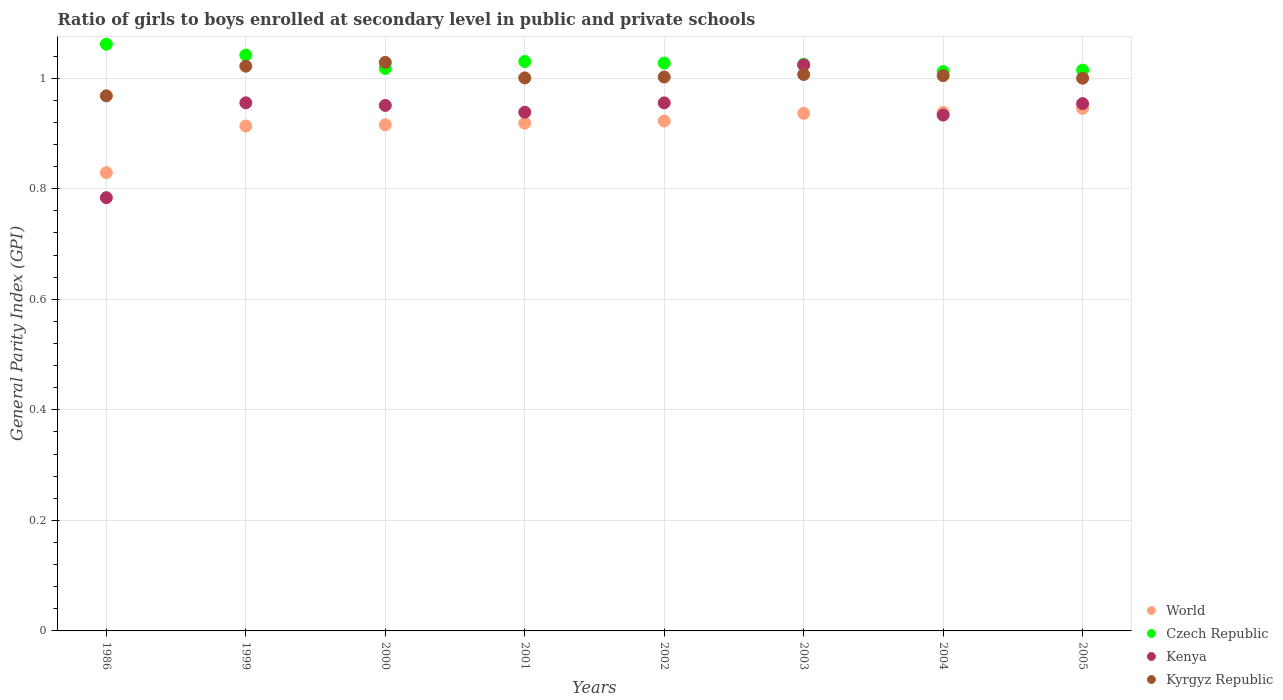Is the number of dotlines equal to the number of legend labels?
Provide a succinct answer. Yes. What is the general parity index in Kyrgyz Republic in 2000?
Offer a terse response. 1.03. Across all years, what is the maximum general parity index in Czech Republic?
Offer a very short reply. 1.06. Across all years, what is the minimum general parity index in World?
Provide a short and direct response. 0.83. In which year was the general parity index in Kenya minimum?
Make the answer very short. 1986. What is the total general parity index in Czech Republic in the graph?
Make the answer very short. 8.23. What is the difference between the general parity index in Czech Republic in 1999 and that in 2005?
Give a very brief answer. 0.03. What is the difference between the general parity index in Kenya in 2003 and the general parity index in Czech Republic in 1999?
Offer a terse response. -0.02. What is the average general parity index in World per year?
Ensure brevity in your answer.  0.92. In the year 2003, what is the difference between the general parity index in Czech Republic and general parity index in Kyrgyz Republic?
Provide a short and direct response. 0.02. What is the ratio of the general parity index in World in 1986 to that in 2001?
Provide a short and direct response. 0.9. Is the difference between the general parity index in Czech Republic in 2000 and 2004 greater than the difference between the general parity index in Kyrgyz Republic in 2000 and 2004?
Make the answer very short. No. What is the difference between the highest and the second highest general parity index in Kenya?
Provide a succinct answer. 0.07. What is the difference between the highest and the lowest general parity index in Kyrgyz Republic?
Give a very brief answer. 0.06. Does the general parity index in Kenya monotonically increase over the years?
Your answer should be compact. No. How many dotlines are there?
Offer a terse response. 4. Are the values on the major ticks of Y-axis written in scientific E-notation?
Make the answer very short. No. Does the graph contain any zero values?
Your response must be concise. No. What is the title of the graph?
Make the answer very short. Ratio of girls to boys enrolled at secondary level in public and private schools. Does "Vanuatu" appear as one of the legend labels in the graph?
Provide a short and direct response. No. What is the label or title of the Y-axis?
Ensure brevity in your answer.  General Parity Index (GPI). What is the General Parity Index (GPI) in World in 1986?
Provide a succinct answer. 0.83. What is the General Parity Index (GPI) of Czech Republic in 1986?
Provide a succinct answer. 1.06. What is the General Parity Index (GPI) in Kenya in 1986?
Keep it short and to the point. 0.78. What is the General Parity Index (GPI) of Kyrgyz Republic in 1986?
Offer a terse response. 0.97. What is the General Parity Index (GPI) of World in 1999?
Provide a succinct answer. 0.91. What is the General Parity Index (GPI) in Czech Republic in 1999?
Give a very brief answer. 1.04. What is the General Parity Index (GPI) of Kenya in 1999?
Make the answer very short. 0.96. What is the General Parity Index (GPI) in Kyrgyz Republic in 1999?
Your response must be concise. 1.02. What is the General Parity Index (GPI) in World in 2000?
Offer a very short reply. 0.92. What is the General Parity Index (GPI) of Czech Republic in 2000?
Offer a very short reply. 1.02. What is the General Parity Index (GPI) of Kenya in 2000?
Give a very brief answer. 0.95. What is the General Parity Index (GPI) in Kyrgyz Republic in 2000?
Give a very brief answer. 1.03. What is the General Parity Index (GPI) in World in 2001?
Keep it short and to the point. 0.92. What is the General Parity Index (GPI) in Czech Republic in 2001?
Offer a very short reply. 1.03. What is the General Parity Index (GPI) in Kenya in 2001?
Offer a terse response. 0.94. What is the General Parity Index (GPI) of Kyrgyz Republic in 2001?
Your answer should be very brief. 1. What is the General Parity Index (GPI) in World in 2002?
Your answer should be compact. 0.92. What is the General Parity Index (GPI) in Czech Republic in 2002?
Your response must be concise. 1.03. What is the General Parity Index (GPI) in Kenya in 2002?
Provide a short and direct response. 0.96. What is the General Parity Index (GPI) in Kyrgyz Republic in 2002?
Your response must be concise. 1. What is the General Parity Index (GPI) of World in 2003?
Ensure brevity in your answer.  0.94. What is the General Parity Index (GPI) in Czech Republic in 2003?
Your answer should be very brief. 1.03. What is the General Parity Index (GPI) of Kenya in 2003?
Provide a short and direct response. 1.02. What is the General Parity Index (GPI) of Kyrgyz Republic in 2003?
Your answer should be very brief. 1.01. What is the General Parity Index (GPI) of World in 2004?
Offer a very short reply. 0.94. What is the General Parity Index (GPI) in Czech Republic in 2004?
Provide a succinct answer. 1.01. What is the General Parity Index (GPI) in Kenya in 2004?
Give a very brief answer. 0.93. What is the General Parity Index (GPI) in Kyrgyz Republic in 2004?
Provide a succinct answer. 1. What is the General Parity Index (GPI) of World in 2005?
Your answer should be very brief. 0.95. What is the General Parity Index (GPI) of Czech Republic in 2005?
Your answer should be compact. 1.01. What is the General Parity Index (GPI) in Kenya in 2005?
Make the answer very short. 0.95. What is the General Parity Index (GPI) of Kyrgyz Republic in 2005?
Your answer should be compact. 1. Across all years, what is the maximum General Parity Index (GPI) of World?
Ensure brevity in your answer.  0.95. Across all years, what is the maximum General Parity Index (GPI) of Czech Republic?
Give a very brief answer. 1.06. Across all years, what is the maximum General Parity Index (GPI) in Kenya?
Offer a terse response. 1.02. Across all years, what is the maximum General Parity Index (GPI) of Kyrgyz Republic?
Offer a very short reply. 1.03. Across all years, what is the minimum General Parity Index (GPI) of World?
Make the answer very short. 0.83. Across all years, what is the minimum General Parity Index (GPI) of Czech Republic?
Provide a short and direct response. 1.01. Across all years, what is the minimum General Parity Index (GPI) of Kenya?
Provide a short and direct response. 0.78. Across all years, what is the minimum General Parity Index (GPI) in Kyrgyz Republic?
Your response must be concise. 0.97. What is the total General Parity Index (GPI) in World in the graph?
Provide a short and direct response. 7.32. What is the total General Parity Index (GPI) of Czech Republic in the graph?
Provide a succinct answer. 8.23. What is the total General Parity Index (GPI) in Kenya in the graph?
Offer a very short reply. 7.5. What is the total General Parity Index (GPI) in Kyrgyz Republic in the graph?
Provide a short and direct response. 8.03. What is the difference between the General Parity Index (GPI) in World in 1986 and that in 1999?
Provide a short and direct response. -0.08. What is the difference between the General Parity Index (GPI) of Czech Republic in 1986 and that in 1999?
Your response must be concise. 0.02. What is the difference between the General Parity Index (GPI) of Kenya in 1986 and that in 1999?
Your answer should be very brief. -0.17. What is the difference between the General Parity Index (GPI) of Kyrgyz Republic in 1986 and that in 1999?
Your answer should be very brief. -0.05. What is the difference between the General Parity Index (GPI) of World in 1986 and that in 2000?
Keep it short and to the point. -0.09. What is the difference between the General Parity Index (GPI) in Czech Republic in 1986 and that in 2000?
Ensure brevity in your answer.  0.04. What is the difference between the General Parity Index (GPI) in Kenya in 1986 and that in 2000?
Your response must be concise. -0.17. What is the difference between the General Parity Index (GPI) of Kyrgyz Republic in 1986 and that in 2000?
Provide a short and direct response. -0.06. What is the difference between the General Parity Index (GPI) of World in 1986 and that in 2001?
Offer a terse response. -0.09. What is the difference between the General Parity Index (GPI) in Czech Republic in 1986 and that in 2001?
Offer a very short reply. 0.03. What is the difference between the General Parity Index (GPI) of Kenya in 1986 and that in 2001?
Your response must be concise. -0.15. What is the difference between the General Parity Index (GPI) in Kyrgyz Republic in 1986 and that in 2001?
Your answer should be very brief. -0.03. What is the difference between the General Parity Index (GPI) in World in 1986 and that in 2002?
Your answer should be compact. -0.09. What is the difference between the General Parity Index (GPI) of Czech Republic in 1986 and that in 2002?
Offer a very short reply. 0.03. What is the difference between the General Parity Index (GPI) of Kenya in 1986 and that in 2002?
Your answer should be compact. -0.17. What is the difference between the General Parity Index (GPI) in Kyrgyz Republic in 1986 and that in 2002?
Keep it short and to the point. -0.03. What is the difference between the General Parity Index (GPI) of World in 1986 and that in 2003?
Offer a very short reply. -0.11. What is the difference between the General Parity Index (GPI) of Czech Republic in 1986 and that in 2003?
Give a very brief answer. 0.04. What is the difference between the General Parity Index (GPI) of Kenya in 1986 and that in 2003?
Keep it short and to the point. -0.24. What is the difference between the General Parity Index (GPI) of Kyrgyz Republic in 1986 and that in 2003?
Provide a short and direct response. -0.04. What is the difference between the General Parity Index (GPI) of World in 1986 and that in 2004?
Offer a very short reply. -0.11. What is the difference between the General Parity Index (GPI) in Czech Republic in 1986 and that in 2004?
Provide a short and direct response. 0.05. What is the difference between the General Parity Index (GPI) of Kenya in 1986 and that in 2004?
Offer a very short reply. -0.15. What is the difference between the General Parity Index (GPI) of Kyrgyz Republic in 1986 and that in 2004?
Make the answer very short. -0.04. What is the difference between the General Parity Index (GPI) in World in 1986 and that in 2005?
Provide a short and direct response. -0.12. What is the difference between the General Parity Index (GPI) of Czech Republic in 1986 and that in 2005?
Provide a short and direct response. 0.05. What is the difference between the General Parity Index (GPI) of Kenya in 1986 and that in 2005?
Offer a very short reply. -0.17. What is the difference between the General Parity Index (GPI) of Kyrgyz Republic in 1986 and that in 2005?
Your answer should be very brief. -0.03. What is the difference between the General Parity Index (GPI) of World in 1999 and that in 2000?
Keep it short and to the point. -0. What is the difference between the General Parity Index (GPI) in Czech Republic in 1999 and that in 2000?
Your response must be concise. 0.02. What is the difference between the General Parity Index (GPI) in Kenya in 1999 and that in 2000?
Provide a succinct answer. 0. What is the difference between the General Parity Index (GPI) in Kyrgyz Republic in 1999 and that in 2000?
Offer a terse response. -0.01. What is the difference between the General Parity Index (GPI) of World in 1999 and that in 2001?
Provide a succinct answer. -0.01. What is the difference between the General Parity Index (GPI) in Czech Republic in 1999 and that in 2001?
Make the answer very short. 0.01. What is the difference between the General Parity Index (GPI) of Kenya in 1999 and that in 2001?
Provide a succinct answer. 0.02. What is the difference between the General Parity Index (GPI) in Kyrgyz Republic in 1999 and that in 2001?
Offer a very short reply. 0.02. What is the difference between the General Parity Index (GPI) in World in 1999 and that in 2002?
Your answer should be very brief. -0.01. What is the difference between the General Parity Index (GPI) in Czech Republic in 1999 and that in 2002?
Your response must be concise. 0.01. What is the difference between the General Parity Index (GPI) in Kyrgyz Republic in 1999 and that in 2002?
Your answer should be compact. 0.02. What is the difference between the General Parity Index (GPI) of World in 1999 and that in 2003?
Your answer should be very brief. -0.02. What is the difference between the General Parity Index (GPI) in Czech Republic in 1999 and that in 2003?
Your answer should be very brief. 0.02. What is the difference between the General Parity Index (GPI) of Kenya in 1999 and that in 2003?
Provide a short and direct response. -0.07. What is the difference between the General Parity Index (GPI) of Kyrgyz Republic in 1999 and that in 2003?
Your answer should be very brief. 0.01. What is the difference between the General Parity Index (GPI) in World in 1999 and that in 2004?
Your answer should be compact. -0.02. What is the difference between the General Parity Index (GPI) in Czech Republic in 1999 and that in 2004?
Your answer should be compact. 0.03. What is the difference between the General Parity Index (GPI) of Kenya in 1999 and that in 2004?
Provide a short and direct response. 0.02. What is the difference between the General Parity Index (GPI) of Kyrgyz Republic in 1999 and that in 2004?
Provide a succinct answer. 0.02. What is the difference between the General Parity Index (GPI) in World in 1999 and that in 2005?
Offer a terse response. -0.03. What is the difference between the General Parity Index (GPI) in Czech Republic in 1999 and that in 2005?
Offer a terse response. 0.03. What is the difference between the General Parity Index (GPI) of Kenya in 1999 and that in 2005?
Offer a terse response. 0. What is the difference between the General Parity Index (GPI) in Kyrgyz Republic in 1999 and that in 2005?
Make the answer very short. 0.02. What is the difference between the General Parity Index (GPI) of World in 2000 and that in 2001?
Your response must be concise. -0. What is the difference between the General Parity Index (GPI) of Czech Republic in 2000 and that in 2001?
Offer a very short reply. -0.01. What is the difference between the General Parity Index (GPI) in Kenya in 2000 and that in 2001?
Your answer should be compact. 0.01. What is the difference between the General Parity Index (GPI) of Kyrgyz Republic in 2000 and that in 2001?
Offer a terse response. 0.03. What is the difference between the General Parity Index (GPI) in World in 2000 and that in 2002?
Ensure brevity in your answer.  -0.01. What is the difference between the General Parity Index (GPI) in Czech Republic in 2000 and that in 2002?
Offer a terse response. -0.01. What is the difference between the General Parity Index (GPI) in Kenya in 2000 and that in 2002?
Your answer should be compact. -0. What is the difference between the General Parity Index (GPI) in Kyrgyz Republic in 2000 and that in 2002?
Offer a very short reply. 0.03. What is the difference between the General Parity Index (GPI) in World in 2000 and that in 2003?
Make the answer very short. -0.02. What is the difference between the General Parity Index (GPI) in Czech Republic in 2000 and that in 2003?
Make the answer very short. -0.01. What is the difference between the General Parity Index (GPI) in Kenya in 2000 and that in 2003?
Give a very brief answer. -0.07. What is the difference between the General Parity Index (GPI) of Kyrgyz Republic in 2000 and that in 2003?
Offer a very short reply. 0.02. What is the difference between the General Parity Index (GPI) of World in 2000 and that in 2004?
Your answer should be very brief. -0.02. What is the difference between the General Parity Index (GPI) of Czech Republic in 2000 and that in 2004?
Provide a succinct answer. 0.01. What is the difference between the General Parity Index (GPI) in Kenya in 2000 and that in 2004?
Keep it short and to the point. 0.02. What is the difference between the General Parity Index (GPI) of Kyrgyz Republic in 2000 and that in 2004?
Ensure brevity in your answer.  0.02. What is the difference between the General Parity Index (GPI) in World in 2000 and that in 2005?
Your answer should be very brief. -0.03. What is the difference between the General Parity Index (GPI) in Czech Republic in 2000 and that in 2005?
Your answer should be compact. 0. What is the difference between the General Parity Index (GPI) in Kenya in 2000 and that in 2005?
Your answer should be compact. -0. What is the difference between the General Parity Index (GPI) in Kyrgyz Republic in 2000 and that in 2005?
Make the answer very short. 0.03. What is the difference between the General Parity Index (GPI) in World in 2001 and that in 2002?
Your answer should be compact. -0. What is the difference between the General Parity Index (GPI) of Czech Republic in 2001 and that in 2002?
Offer a terse response. 0. What is the difference between the General Parity Index (GPI) in Kenya in 2001 and that in 2002?
Make the answer very short. -0.02. What is the difference between the General Parity Index (GPI) of Kyrgyz Republic in 2001 and that in 2002?
Keep it short and to the point. -0. What is the difference between the General Parity Index (GPI) in World in 2001 and that in 2003?
Make the answer very short. -0.02. What is the difference between the General Parity Index (GPI) in Czech Republic in 2001 and that in 2003?
Your answer should be very brief. 0.01. What is the difference between the General Parity Index (GPI) in Kenya in 2001 and that in 2003?
Your answer should be very brief. -0.09. What is the difference between the General Parity Index (GPI) in Kyrgyz Republic in 2001 and that in 2003?
Ensure brevity in your answer.  -0.01. What is the difference between the General Parity Index (GPI) in World in 2001 and that in 2004?
Provide a short and direct response. -0.02. What is the difference between the General Parity Index (GPI) of Czech Republic in 2001 and that in 2004?
Provide a short and direct response. 0.02. What is the difference between the General Parity Index (GPI) in Kenya in 2001 and that in 2004?
Your response must be concise. 0.01. What is the difference between the General Parity Index (GPI) of Kyrgyz Republic in 2001 and that in 2004?
Provide a short and direct response. -0. What is the difference between the General Parity Index (GPI) of World in 2001 and that in 2005?
Provide a short and direct response. -0.03. What is the difference between the General Parity Index (GPI) in Czech Republic in 2001 and that in 2005?
Your answer should be very brief. 0.02. What is the difference between the General Parity Index (GPI) of Kenya in 2001 and that in 2005?
Your answer should be very brief. -0.02. What is the difference between the General Parity Index (GPI) of Kyrgyz Republic in 2001 and that in 2005?
Provide a short and direct response. 0. What is the difference between the General Parity Index (GPI) in World in 2002 and that in 2003?
Ensure brevity in your answer.  -0.01. What is the difference between the General Parity Index (GPI) of Czech Republic in 2002 and that in 2003?
Provide a short and direct response. 0. What is the difference between the General Parity Index (GPI) in Kenya in 2002 and that in 2003?
Your answer should be compact. -0.07. What is the difference between the General Parity Index (GPI) of Kyrgyz Republic in 2002 and that in 2003?
Provide a short and direct response. -0. What is the difference between the General Parity Index (GPI) in World in 2002 and that in 2004?
Your answer should be very brief. -0.02. What is the difference between the General Parity Index (GPI) in Czech Republic in 2002 and that in 2004?
Offer a very short reply. 0.02. What is the difference between the General Parity Index (GPI) of Kenya in 2002 and that in 2004?
Provide a short and direct response. 0.02. What is the difference between the General Parity Index (GPI) in Kyrgyz Republic in 2002 and that in 2004?
Provide a short and direct response. -0. What is the difference between the General Parity Index (GPI) in World in 2002 and that in 2005?
Your answer should be very brief. -0.02. What is the difference between the General Parity Index (GPI) in Czech Republic in 2002 and that in 2005?
Offer a very short reply. 0.01. What is the difference between the General Parity Index (GPI) in Kenya in 2002 and that in 2005?
Make the answer very short. 0. What is the difference between the General Parity Index (GPI) of Kyrgyz Republic in 2002 and that in 2005?
Your response must be concise. 0. What is the difference between the General Parity Index (GPI) in World in 2003 and that in 2004?
Keep it short and to the point. -0. What is the difference between the General Parity Index (GPI) of Czech Republic in 2003 and that in 2004?
Make the answer very short. 0.01. What is the difference between the General Parity Index (GPI) in Kenya in 2003 and that in 2004?
Offer a very short reply. 0.09. What is the difference between the General Parity Index (GPI) of Kyrgyz Republic in 2003 and that in 2004?
Your response must be concise. 0. What is the difference between the General Parity Index (GPI) in World in 2003 and that in 2005?
Keep it short and to the point. -0.01. What is the difference between the General Parity Index (GPI) of Czech Republic in 2003 and that in 2005?
Provide a succinct answer. 0.01. What is the difference between the General Parity Index (GPI) in Kenya in 2003 and that in 2005?
Your answer should be compact. 0.07. What is the difference between the General Parity Index (GPI) of Kyrgyz Republic in 2003 and that in 2005?
Your response must be concise. 0.01. What is the difference between the General Parity Index (GPI) of World in 2004 and that in 2005?
Offer a terse response. -0.01. What is the difference between the General Parity Index (GPI) of Czech Republic in 2004 and that in 2005?
Your response must be concise. -0. What is the difference between the General Parity Index (GPI) in Kenya in 2004 and that in 2005?
Give a very brief answer. -0.02. What is the difference between the General Parity Index (GPI) of Kyrgyz Republic in 2004 and that in 2005?
Keep it short and to the point. 0. What is the difference between the General Parity Index (GPI) in World in 1986 and the General Parity Index (GPI) in Czech Republic in 1999?
Ensure brevity in your answer.  -0.21. What is the difference between the General Parity Index (GPI) of World in 1986 and the General Parity Index (GPI) of Kenya in 1999?
Offer a very short reply. -0.13. What is the difference between the General Parity Index (GPI) in World in 1986 and the General Parity Index (GPI) in Kyrgyz Republic in 1999?
Provide a short and direct response. -0.19. What is the difference between the General Parity Index (GPI) of Czech Republic in 1986 and the General Parity Index (GPI) of Kenya in 1999?
Provide a short and direct response. 0.11. What is the difference between the General Parity Index (GPI) of Czech Republic in 1986 and the General Parity Index (GPI) of Kyrgyz Republic in 1999?
Ensure brevity in your answer.  0.04. What is the difference between the General Parity Index (GPI) in Kenya in 1986 and the General Parity Index (GPI) in Kyrgyz Republic in 1999?
Provide a short and direct response. -0.24. What is the difference between the General Parity Index (GPI) of World in 1986 and the General Parity Index (GPI) of Czech Republic in 2000?
Your response must be concise. -0.19. What is the difference between the General Parity Index (GPI) in World in 1986 and the General Parity Index (GPI) in Kenya in 2000?
Offer a very short reply. -0.12. What is the difference between the General Parity Index (GPI) of World in 1986 and the General Parity Index (GPI) of Kyrgyz Republic in 2000?
Provide a short and direct response. -0.2. What is the difference between the General Parity Index (GPI) of Czech Republic in 1986 and the General Parity Index (GPI) of Kenya in 2000?
Ensure brevity in your answer.  0.11. What is the difference between the General Parity Index (GPI) in Czech Republic in 1986 and the General Parity Index (GPI) in Kyrgyz Republic in 2000?
Offer a terse response. 0.03. What is the difference between the General Parity Index (GPI) in Kenya in 1986 and the General Parity Index (GPI) in Kyrgyz Republic in 2000?
Your answer should be very brief. -0.24. What is the difference between the General Parity Index (GPI) of World in 1986 and the General Parity Index (GPI) of Czech Republic in 2001?
Make the answer very short. -0.2. What is the difference between the General Parity Index (GPI) in World in 1986 and the General Parity Index (GPI) in Kenya in 2001?
Give a very brief answer. -0.11. What is the difference between the General Parity Index (GPI) of World in 1986 and the General Parity Index (GPI) of Kyrgyz Republic in 2001?
Your answer should be very brief. -0.17. What is the difference between the General Parity Index (GPI) in Czech Republic in 1986 and the General Parity Index (GPI) in Kenya in 2001?
Make the answer very short. 0.12. What is the difference between the General Parity Index (GPI) of Czech Republic in 1986 and the General Parity Index (GPI) of Kyrgyz Republic in 2001?
Your answer should be compact. 0.06. What is the difference between the General Parity Index (GPI) of Kenya in 1986 and the General Parity Index (GPI) of Kyrgyz Republic in 2001?
Provide a short and direct response. -0.22. What is the difference between the General Parity Index (GPI) in World in 1986 and the General Parity Index (GPI) in Czech Republic in 2002?
Ensure brevity in your answer.  -0.2. What is the difference between the General Parity Index (GPI) of World in 1986 and the General Parity Index (GPI) of Kenya in 2002?
Ensure brevity in your answer.  -0.13. What is the difference between the General Parity Index (GPI) of World in 1986 and the General Parity Index (GPI) of Kyrgyz Republic in 2002?
Provide a succinct answer. -0.17. What is the difference between the General Parity Index (GPI) in Czech Republic in 1986 and the General Parity Index (GPI) in Kenya in 2002?
Your answer should be compact. 0.11. What is the difference between the General Parity Index (GPI) in Czech Republic in 1986 and the General Parity Index (GPI) in Kyrgyz Republic in 2002?
Your answer should be compact. 0.06. What is the difference between the General Parity Index (GPI) of Kenya in 1986 and the General Parity Index (GPI) of Kyrgyz Republic in 2002?
Your response must be concise. -0.22. What is the difference between the General Parity Index (GPI) of World in 1986 and the General Parity Index (GPI) of Czech Republic in 2003?
Give a very brief answer. -0.2. What is the difference between the General Parity Index (GPI) of World in 1986 and the General Parity Index (GPI) of Kenya in 2003?
Offer a very short reply. -0.19. What is the difference between the General Parity Index (GPI) in World in 1986 and the General Parity Index (GPI) in Kyrgyz Republic in 2003?
Keep it short and to the point. -0.18. What is the difference between the General Parity Index (GPI) in Czech Republic in 1986 and the General Parity Index (GPI) in Kenya in 2003?
Provide a short and direct response. 0.04. What is the difference between the General Parity Index (GPI) of Czech Republic in 1986 and the General Parity Index (GPI) of Kyrgyz Republic in 2003?
Provide a succinct answer. 0.05. What is the difference between the General Parity Index (GPI) of Kenya in 1986 and the General Parity Index (GPI) of Kyrgyz Republic in 2003?
Make the answer very short. -0.22. What is the difference between the General Parity Index (GPI) in World in 1986 and the General Parity Index (GPI) in Czech Republic in 2004?
Offer a very short reply. -0.18. What is the difference between the General Parity Index (GPI) of World in 1986 and the General Parity Index (GPI) of Kenya in 2004?
Give a very brief answer. -0.1. What is the difference between the General Parity Index (GPI) in World in 1986 and the General Parity Index (GPI) in Kyrgyz Republic in 2004?
Provide a short and direct response. -0.18. What is the difference between the General Parity Index (GPI) in Czech Republic in 1986 and the General Parity Index (GPI) in Kenya in 2004?
Your response must be concise. 0.13. What is the difference between the General Parity Index (GPI) in Czech Republic in 1986 and the General Parity Index (GPI) in Kyrgyz Republic in 2004?
Provide a short and direct response. 0.06. What is the difference between the General Parity Index (GPI) in Kenya in 1986 and the General Parity Index (GPI) in Kyrgyz Republic in 2004?
Keep it short and to the point. -0.22. What is the difference between the General Parity Index (GPI) of World in 1986 and the General Parity Index (GPI) of Czech Republic in 2005?
Offer a terse response. -0.19. What is the difference between the General Parity Index (GPI) of World in 1986 and the General Parity Index (GPI) of Kenya in 2005?
Your answer should be compact. -0.12. What is the difference between the General Parity Index (GPI) of World in 1986 and the General Parity Index (GPI) of Kyrgyz Republic in 2005?
Offer a terse response. -0.17. What is the difference between the General Parity Index (GPI) in Czech Republic in 1986 and the General Parity Index (GPI) in Kenya in 2005?
Make the answer very short. 0.11. What is the difference between the General Parity Index (GPI) of Czech Republic in 1986 and the General Parity Index (GPI) of Kyrgyz Republic in 2005?
Offer a very short reply. 0.06. What is the difference between the General Parity Index (GPI) in Kenya in 1986 and the General Parity Index (GPI) in Kyrgyz Republic in 2005?
Offer a terse response. -0.22. What is the difference between the General Parity Index (GPI) in World in 1999 and the General Parity Index (GPI) in Czech Republic in 2000?
Ensure brevity in your answer.  -0.1. What is the difference between the General Parity Index (GPI) of World in 1999 and the General Parity Index (GPI) of Kenya in 2000?
Give a very brief answer. -0.04. What is the difference between the General Parity Index (GPI) in World in 1999 and the General Parity Index (GPI) in Kyrgyz Republic in 2000?
Your answer should be compact. -0.12. What is the difference between the General Parity Index (GPI) of Czech Republic in 1999 and the General Parity Index (GPI) of Kenya in 2000?
Ensure brevity in your answer.  0.09. What is the difference between the General Parity Index (GPI) of Czech Republic in 1999 and the General Parity Index (GPI) of Kyrgyz Republic in 2000?
Your answer should be very brief. 0.01. What is the difference between the General Parity Index (GPI) of Kenya in 1999 and the General Parity Index (GPI) of Kyrgyz Republic in 2000?
Offer a very short reply. -0.07. What is the difference between the General Parity Index (GPI) of World in 1999 and the General Parity Index (GPI) of Czech Republic in 2001?
Provide a short and direct response. -0.12. What is the difference between the General Parity Index (GPI) in World in 1999 and the General Parity Index (GPI) in Kenya in 2001?
Offer a very short reply. -0.02. What is the difference between the General Parity Index (GPI) of World in 1999 and the General Parity Index (GPI) of Kyrgyz Republic in 2001?
Provide a succinct answer. -0.09. What is the difference between the General Parity Index (GPI) in Czech Republic in 1999 and the General Parity Index (GPI) in Kenya in 2001?
Offer a very short reply. 0.1. What is the difference between the General Parity Index (GPI) of Czech Republic in 1999 and the General Parity Index (GPI) of Kyrgyz Republic in 2001?
Make the answer very short. 0.04. What is the difference between the General Parity Index (GPI) of Kenya in 1999 and the General Parity Index (GPI) of Kyrgyz Republic in 2001?
Keep it short and to the point. -0.05. What is the difference between the General Parity Index (GPI) in World in 1999 and the General Parity Index (GPI) in Czech Republic in 2002?
Provide a succinct answer. -0.11. What is the difference between the General Parity Index (GPI) in World in 1999 and the General Parity Index (GPI) in Kenya in 2002?
Make the answer very short. -0.04. What is the difference between the General Parity Index (GPI) in World in 1999 and the General Parity Index (GPI) in Kyrgyz Republic in 2002?
Your answer should be very brief. -0.09. What is the difference between the General Parity Index (GPI) of Czech Republic in 1999 and the General Parity Index (GPI) of Kenya in 2002?
Your answer should be very brief. 0.09. What is the difference between the General Parity Index (GPI) of Czech Republic in 1999 and the General Parity Index (GPI) of Kyrgyz Republic in 2002?
Offer a very short reply. 0.04. What is the difference between the General Parity Index (GPI) of Kenya in 1999 and the General Parity Index (GPI) of Kyrgyz Republic in 2002?
Keep it short and to the point. -0.05. What is the difference between the General Parity Index (GPI) in World in 1999 and the General Parity Index (GPI) in Czech Republic in 2003?
Provide a succinct answer. -0.11. What is the difference between the General Parity Index (GPI) in World in 1999 and the General Parity Index (GPI) in Kenya in 2003?
Make the answer very short. -0.11. What is the difference between the General Parity Index (GPI) of World in 1999 and the General Parity Index (GPI) of Kyrgyz Republic in 2003?
Provide a short and direct response. -0.09. What is the difference between the General Parity Index (GPI) of Czech Republic in 1999 and the General Parity Index (GPI) of Kenya in 2003?
Give a very brief answer. 0.02. What is the difference between the General Parity Index (GPI) of Czech Republic in 1999 and the General Parity Index (GPI) of Kyrgyz Republic in 2003?
Offer a terse response. 0.04. What is the difference between the General Parity Index (GPI) in Kenya in 1999 and the General Parity Index (GPI) in Kyrgyz Republic in 2003?
Your answer should be very brief. -0.05. What is the difference between the General Parity Index (GPI) of World in 1999 and the General Parity Index (GPI) of Czech Republic in 2004?
Your answer should be compact. -0.1. What is the difference between the General Parity Index (GPI) in World in 1999 and the General Parity Index (GPI) in Kenya in 2004?
Provide a succinct answer. -0.02. What is the difference between the General Parity Index (GPI) of World in 1999 and the General Parity Index (GPI) of Kyrgyz Republic in 2004?
Make the answer very short. -0.09. What is the difference between the General Parity Index (GPI) of Czech Republic in 1999 and the General Parity Index (GPI) of Kenya in 2004?
Keep it short and to the point. 0.11. What is the difference between the General Parity Index (GPI) of Czech Republic in 1999 and the General Parity Index (GPI) of Kyrgyz Republic in 2004?
Keep it short and to the point. 0.04. What is the difference between the General Parity Index (GPI) of Kenya in 1999 and the General Parity Index (GPI) of Kyrgyz Republic in 2004?
Your answer should be very brief. -0.05. What is the difference between the General Parity Index (GPI) of World in 1999 and the General Parity Index (GPI) of Czech Republic in 2005?
Make the answer very short. -0.1. What is the difference between the General Parity Index (GPI) of World in 1999 and the General Parity Index (GPI) of Kenya in 2005?
Give a very brief answer. -0.04. What is the difference between the General Parity Index (GPI) in World in 1999 and the General Parity Index (GPI) in Kyrgyz Republic in 2005?
Your answer should be compact. -0.09. What is the difference between the General Parity Index (GPI) in Czech Republic in 1999 and the General Parity Index (GPI) in Kenya in 2005?
Ensure brevity in your answer.  0.09. What is the difference between the General Parity Index (GPI) in Czech Republic in 1999 and the General Parity Index (GPI) in Kyrgyz Republic in 2005?
Your answer should be very brief. 0.04. What is the difference between the General Parity Index (GPI) of Kenya in 1999 and the General Parity Index (GPI) of Kyrgyz Republic in 2005?
Give a very brief answer. -0.04. What is the difference between the General Parity Index (GPI) of World in 2000 and the General Parity Index (GPI) of Czech Republic in 2001?
Ensure brevity in your answer.  -0.11. What is the difference between the General Parity Index (GPI) in World in 2000 and the General Parity Index (GPI) in Kenya in 2001?
Make the answer very short. -0.02. What is the difference between the General Parity Index (GPI) in World in 2000 and the General Parity Index (GPI) in Kyrgyz Republic in 2001?
Make the answer very short. -0.08. What is the difference between the General Parity Index (GPI) of Czech Republic in 2000 and the General Parity Index (GPI) of Kenya in 2001?
Keep it short and to the point. 0.08. What is the difference between the General Parity Index (GPI) of Czech Republic in 2000 and the General Parity Index (GPI) of Kyrgyz Republic in 2001?
Give a very brief answer. 0.02. What is the difference between the General Parity Index (GPI) in Kenya in 2000 and the General Parity Index (GPI) in Kyrgyz Republic in 2001?
Offer a terse response. -0.05. What is the difference between the General Parity Index (GPI) of World in 2000 and the General Parity Index (GPI) of Czech Republic in 2002?
Keep it short and to the point. -0.11. What is the difference between the General Parity Index (GPI) in World in 2000 and the General Parity Index (GPI) in Kenya in 2002?
Ensure brevity in your answer.  -0.04. What is the difference between the General Parity Index (GPI) in World in 2000 and the General Parity Index (GPI) in Kyrgyz Republic in 2002?
Ensure brevity in your answer.  -0.09. What is the difference between the General Parity Index (GPI) of Czech Republic in 2000 and the General Parity Index (GPI) of Kenya in 2002?
Ensure brevity in your answer.  0.06. What is the difference between the General Parity Index (GPI) in Czech Republic in 2000 and the General Parity Index (GPI) in Kyrgyz Republic in 2002?
Your answer should be compact. 0.02. What is the difference between the General Parity Index (GPI) in Kenya in 2000 and the General Parity Index (GPI) in Kyrgyz Republic in 2002?
Your answer should be very brief. -0.05. What is the difference between the General Parity Index (GPI) in World in 2000 and the General Parity Index (GPI) in Czech Republic in 2003?
Provide a short and direct response. -0.11. What is the difference between the General Parity Index (GPI) in World in 2000 and the General Parity Index (GPI) in Kenya in 2003?
Give a very brief answer. -0.11. What is the difference between the General Parity Index (GPI) of World in 2000 and the General Parity Index (GPI) of Kyrgyz Republic in 2003?
Provide a short and direct response. -0.09. What is the difference between the General Parity Index (GPI) of Czech Republic in 2000 and the General Parity Index (GPI) of Kenya in 2003?
Provide a short and direct response. -0.01. What is the difference between the General Parity Index (GPI) in Czech Republic in 2000 and the General Parity Index (GPI) in Kyrgyz Republic in 2003?
Keep it short and to the point. 0.01. What is the difference between the General Parity Index (GPI) in Kenya in 2000 and the General Parity Index (GPI) in Kyrgyz Republic in 2003?
Make the answer very short. -0.06. What is the difference between the General Parity Index (GPI) of World in 2000 and the General Parity Index (GPI) of Czech Republic in 2004?
Your answer should be compact. -0.1. What is the difference between the General Parity Index (GPI) of World in 2000 and the General Parity Index (GPI) of Kenya in 2004?
Keep it short and to the point. -0.02. What is the difference between the General Parity Index (GPI) of World in 2000 and the General Parity Index (GPI) of Kyrgyz Republic in 2004?
Provide a succinct answer. -0.09. What is the difference between the General Parity Index (GPI) of Czech Republic in 2000 and the General Parity Index (GPI) of Kenya in 2004?
Offer a very short reply. 0.08. What is the difference between the General Parity Index (GPI) of Czech Republic in 2000 and the General Parity Index (GPI) of Kyrgyz Republic in 2004?
Your response must be concise. 0.01. What is the difference between the General Parity Index (GPI) in Kenya in 2000 and the General Parity Index (GPI) in Kyrgyz Republic in 2004?
Offer a very short reply. -0.05. What is the difference between the General Parity Index (GPI) of World in 2000 and the General Parity Index (GPI) of Czech Republic in 2005?
Give a very brief answer. -0.1. What is the difference between the General Parity Index (GPI) in World in 2000 and the General Parity Index (GPI) in Kenya in 2005?
Make the answer very short. -0.04. What is the difference between the General Parity Index (GPI) of World in 2000 and the General Parity Index (GPI) of Kyrgyz Republic in 2005?
Your answer should be very brief. -0.08. What is the difference between the General Parity Index (GPI) of Czech Republic in 2000 and the General Parity Index (GPI) of Kenya in 2005?
Ensure brevity in your answer.  0.06. What is the difference between the General Parity Index (GPI) in Czech Republic in 2000 and the General Parity Index (GPI) in Kyrgyz Republic in 2005?
Provide a succinct answer. 0.02. What is the difference between the General Parity Index (GPI) in Kenya in 2000 and the General Parity Index (GPI) in Kyrgyz Republic in 2005?
Provide a succinct answer. -0.05. What is the difference between the General Parity Index (GPI) in World in 2001 and the General Parity Index (GPI) in Czech Republic in 2002?
Your answer should be very brief. -0.11. What is the difference between the General Parity Index (GPI) of World in 2001 and the General Parity Index (GPI) of Kenya in 2002?
Ensure brevity in your answer.  -0.04. What is the difference between the General Parity Index (GPI) of World in 2001 and the General Parity Index (GPI) of Kyrgyz Republic in 2002?
Your answer should be very brief. -0.08. What is the difference between the General Parity Index (GPI) of Czech Republic in 2001 and the General Parity Index (GPI) of Kenya in 2002?
Make the answer very short. 0.07. What is the difference between the General Parity Index (GPI) of Czech Republic in 2001 and the General Parity Index (GPI) of Kyrgyz Republic in 2002?
Ensure brevity in your answer.  0.03. What is the difference between the General Parity Index (GPI) of Kenya in 2001 and the General Parity Index (GPI) of Kyrgyz Republic in 2002?
Provide a short and direct response. -0.06. What is the difference between the General Parity Index (GPI) in World in 2001 and the General Parity Index (GPI) in Czech Republic in 2003?
Ensure brevity in your answer.  -0.11. What is the difference between the General Parity Index (GPI) in World in 2001 and the General Parity Index (GPI) in Kenya in 2003?
Your answer should be compact. -0.11. What is the difference between the General Parity Index (GPI) of World in 2001 and the General Parity Index (GPI) of Kyrgyz Republic in 2003?
Offer a terse response. -0.09. What is the difference between the General Parity Index (GPI) of Czech Republic in 2001 and the General Parity Index (GPI) of Kenya in 2003?
Ensure brevity in your answer.  0.01. What is the difference between the General Parity Index (GPI) of Czech Republic in 2001 and the General Parity Index (GPI) of Kyrgyz Republic in 2003?
Keep it short and to the point. 0.02. What is the difference between the General Parity Index (GPI) of Kenya in 2001 and the General Parity Index (GPI) of Kyrgyz Republic in 2003?
Offer a very short reply. -0.07. What is the difference between the General Parity Index (GPI) of World in 2001 and the General Parity Index (GPI) of Czech Republic in 2004?
Offer a terse response. -0.09. What is the difference between the General Parity Index (GPI) of World in 2001 and the General Parity Index (GPI) of Kenya in 2004?
Ensure brevity in your answer.  -0.01. What is the difference between the General Parity Index (GPI) in World in 2001 and the General Parity Index (GPI) in Kyrgyz Republic in 2004?
Offer a terse response. -0.09. What is the difference between the General Parity Index (GPI) in Czech Republic in 2001 and the General Parity Index (GPI) in Kenya in 2004?
Provide a short and direct response. 0.1. What is the difference between the General Parity Index (GPI) of Czech Republic in 2001 and the General Parity Index (GPI) of Kyrgyz Republic in 2004?
Provide a short and direct response. 0.03. What is the difference between the General Parity Index (GPI) of Kenya in 2001 and the General Parity Index (GPI) of Kyrgyz Republic in 2004?
Ensure brevity in your answer.  -0.07. What is the difference between the General Parity Index (GPI) in World in 2001 and the General Parity Index (GPI) in Czech Republic in 2005?
Ensure brevity in your answer.  -0.1. What is the difference between the General Parity Index (GPI) of World in 2001 and the General Parity Index (GPI) of Kenya in 2005?
Your response must be concise. -0.04. What is the difference between the General Parity Index (GPI) in World in 2001 and the General Parity Index (GPI) in Kyrgyz Republic in 2005?
Your response must be concise. -0.08. What is the difference between the General Parity Index (GPI) of Czech Republic in 2001 and the General Parity Index (GPI) of Kenya in 2005?
Keep it short and to the point. 0.08. What is the difference between the General Parity Index (GPI) in Czech Republic in 2001 and the General Parity Index (GPI) in Kyrgyz Republic in 2005?
Your response must be concise. 0.03. What is the difference between the General Parity Index (GPI) in Kenya in 2001 and the General Parity Index (GPI) in Kyrgyz Republic in 2005?
Your response must be concise. -0.06. What is the difference between the General Parity Index (GPI) of World in 2002 and the General Parity Index (GPI) of Czech Republic in 2003?
Offer a very short reply. -0.1. What is the difference between the General Parity Index (GPI) of World in 2002 and the General Parity Index (GPI) of Kenya in 2003?
Your response must be concise. -0.1. What is the difference between the General Parity Index (GPI) in World in 2002 and the General Parity Index (GPI) in Kyrgyz Republic in 2003?
Your answer should be very brief. -0.08. What is the difference between the General Parity Index (GPI) in Czech Republic in 2002 and the General Parity Index (GPI) in Kenya in 2003?
Give a very brief answer. 0. What is the difference between the General Parity Index (GPI) of Czech Republic in 2002 and the General Parity Index (GPI) of Kyrgyz Republic in 2003?
Keep it short and to the point. 0.02. What is the difference between the General Parity Index (GPI) in Kenya in 2002 and the General Parity Index (GPI) in Kyrgyz Republic in 2003?
Your response must be concise. -0.05. What is the difference between the General Parity Index (GPI) of World in 2002 and the General Parity Index (GPI) of Czech Republic in 2004?
Ensure brevity in your answer.  -0.09. What is the difference between the General Parity Index (GPI) of World in 2002 and the General Parity Index (GPI) of Kenya in 2004?
Your response must be concise. -0.01. What is the difference between the General Parity Index (GPI) of World in 2002 and the General Parity Index (GPI) of Kyrgyz Republic in 2004?
Offer a terse response. -0.08. What is the difference between the General Parity Index (GPI) in Czech Republic in 2002 and the General Parity Index (GPI) in Kenya in 2004?
Your response must be concise. 0.09. What is the difference between the General Parity Index (GPI) in Czech Republic in 2002 and the General Parity Index (GPI) in Kyrgyz Republic in 2004?
Keep it short and to the point. 0.02. What is the difference between the General Parity Index (GPI) in Kenya in 2002 and the General Parity Index (GPI) in Kyrgyz Republic in 2004?
Your response must be concise. -0.05. What is the difference between the General Parity Index (GPI) of World in 2002 and the General Parity Index (GPI) of Czech Republic in 2005?
Your response must be concise. -0.09. What is the difference between the General Parity Index (GPI) of World in 2002 and the General Parity Index (GPI) of Kenya in 2005?
Make the answer very short. -0.03. What is the difference between the General Parity Index (GPI) of World in 2002 and the General Parity Index (GPI) of Kyrgyz Republic in 2005?
Provide a succinct answer. -0.08. What is the difference between the General Parity Index (GPI) in Czech Republic in 2002 and the General Parity Index (GPI) in Kenya in 2005?
Your response must be concise. 0.07. What is the difference between the General Parity Index (GPI) of Czech Republic in 2002 and the General Parity Index (GPI) of Kyrgyz Republic in 2005?
Your answer should be very brief. 0.03. What is the difference between the General Parity Index (GPI) in Kenya in 2002 and the General Parity Index (GPI) in Kyrgyz Republic in 2005?
Your response must be concise. -0.04. What is the difference between the General Parity Index (GPI) in World in 2003 and the General Parity Index (GPI) in Czech Republic in 2004?
Offer a terse response. -0.08. What is the difference between the General Parity Index (GPI) of World in 2003 and the General Parity Index (GPI) of Kenya in 2004?
Provide a succinct answer. 0. What is the difference between the General Parity Index (GPI) in World in 2003 and the General Parity Index (GPI) in Kyrgyz Republic in 2004?
Give a very brief answer. -0.07. What is the difference between the General Parity Index (GPI) of Czech Republic in 2003 and the General Parity Index (GPI) of Kenya in 2004?
Offer a terse response. 0.09. What is the difference between the General Parity Index (GPI) in Czech Republic in 2003 and the General Parity Index (GPI) in Kyrgyz Republic in 2004?
Ensure brevity in your answer.  0.02. What is the difference between the General Parity Index (GPI) of Kenya in 2003 and the General Parity Index (GPI) of Kyrgyz Republic in 2004?
Your response must be concise. 0.02. What is the difference between the General Parity Index (GPI) in World in 2003 and the General Parity Index (GPI) in Czech Republic in 2005?
Your answer should be very brief. -0.08. What is the difference between the General Parity Index (GPI) in World in 2003 and the General Parity Index (GPI) in Kenya in 2005?
Offer a very short reply. -0.02. What is the difference between the General Parity Index (GPI) in World in 2003 and the General Parity Index (GPI) in Kyrgyz Republic in 2005?
Give a very brief answer. -0.06. What is the difference between the General Parity Index (GPI) of Czech Republic in 2003 and the General Parity Index (GPI) of Kenya in 2005?
Your answer should be very brief. 0.07. What is the difference between the General Parity Index (GPI) of Czech Republic in 2003 and the General Parity Index (GPI) of Kyrgyz Republic in 2005?
Offer a terse response. 0.03. What is the difference between the General Parity Index (GPI) in Kenya in 2003 and the General Parity Index (GPI) in Kyrgyz Republic in 2005?
Offer a very short reply. 0.02. What is the difference between the General Parity Index (GPI) in World in 2004 and the General Parity Index (GPI) in Czech Republic in 2005?
Offer a terse response. -0.08. What is the difference between the General Parity Index (GPI) in World in 2004 and the General Parity Index (GPI) in Kenya in 2005?
Ensure brevity in your answer.  -0.02. What is the difference between the General Parity Index (GPI) in World in 2004 and the General Parity Index (GPI) in Kyrgyz Republic in 2005?
Your answer should be very brief. -0.06. What is the difference between the General Parity Index (GPI) in Czech Republic in 2004 and the General Parity Index (GPI) in Kenya in 2005?
Give a very brief answer. 0.06. What is the difference between the General Parity Index (GPI) in Czech Republic in 2004 and the General Parity Index (GPI) in Kyrgyz Republic in 2005?
Keep it short and to the point. 0.01. What is the difference between the General Parity Index (GPI) in Kenya in 2004 and the General Parity Index (GPI) in Kyrgyz Republic in 2005?
Provide a short and direct response. -0.07. What is the average General Parity Index (GPI) of World per year?
Your response must be concise. 0.92. What is the average General Parity Index (GPI) in Czech Republic per year?
Keep it short and to the point. 1.03. What is the average General Parity Index (GPI) in Kenya per year?
Your response must be concise. 0.94. In the year 1986, what is the difference between the General Parity Index (GPI) of World and General Parity Index (GPI) of Czech Republic?
Ensure brevity in your answer.  -0.23. In the year 1986, what is the difference between the General Parity Index (GPI) of World and General Parity Index (GPI) of Kenya?
Provide a short and direct response. 0.05. In the year 1986, what is the difference between the General Parity Index (GPI) of World and General Parity Index (GPI) of Kyrgyz Republic?
Your answer should be very brief. -0.14. In the year 1986, what is the difference between the General Parity Index (GPI) in Czech Republic and General Parity Index (GPI) in Kenya?
Provide a short and direct response. 0.28. In the year 1986, what is the difference between the General Parity Index (GPI) in Czech Republic and General Parity Index (GPI) in Kyrgyz Republic?
Keep it short and to the point. 0.09. In the year 1986, what is the difference between the General Parity Index (GPI) of Kenya and General Parity Index (GPI) of Kyrgyz Republic?
Provide a short and direct response. -0.18. In the year 1999, what is the difference between the General Parity Index (GPI) of World and General Parity Index (GPI) of Czech Republic?
Your answer should be very brief. -0.13. In the year 1999, what is the difference between the General Parity Index (GPI) in World and General Parity Index (GPI) in Kenya?
Keep it short and to the point. -0.04. In the year 1999, what is the difference between the General Parity Index (GPI) in World and General Parity Index (GPI) in Kyrgyz Republic?
Your response must be concise. -0.11. In the year 1999, what is the difference between the General Parity Index (GPI) in Czech Republic and General Parity Index (GPI) in Kenya?
Your response must be concise. 0.09. In the year 1999, what is the difference between the General Parity Index (GPI) in Czech Republic and General Parity Index (GPI) in Kyrgyz Republic?
Your answer should be compact. 0.02. In the year 1999, what is the difference between the General Parity Index (GPI) in Kenya and General Parity Index (GPI) in Kyrgyz Republic?
Your answer should be compact. -0.07. In the year 2000, what is the difference between the General Parity Index (GPI) of World and General Parity Index (GPI) of Czech Republic?
Offer a very short reply. -0.1. In the year 2000, what is the difference between the General Parity Index (GPI) of World and General Parity Index (GPI) of Kenya?
Give a very brief answer. -0.04. In the year 2000, what is the difference between the General Parity Index (GPI) of World and General Parity Index (GPI) of Kyrgyz Republic?
Offer a terse response. -0.11. In the year 2000, what is the difference between the General Parity Index (GPI) in Czech Republic and General Parity Index (GPI) in Kenya?
Your response must be concise. 0.07. In the year 2000, what is the difference between the General Parity Index (GPI) in Czech Republic and General Parity Index (GPI) in Kyrgyz Republic?
Your answer should be compact. -0.01. In the year 2000, what is the difference between the General Parity Index (GPI) of Kenya and General Parity Index (GPI) of Kyrgyz Republic?
Your response must be concise. -0.08. In the year 2001, what is the difference between the General Parity Index (GPI) in World and General Parity Index (GPI) in Czech Republic?
Give a very brief answer. -0.11. In the year 2001, what is the difference between the General Parity Index (GPI) in World and General Parity Index (GPI) in Kenya?
Your answer should be very brief. -0.02. In the year 2001, what is the difference between the General Parity Index (GPI) of World and General Parity Index (GPI) of Kyrgyz Republic?
Keep it short and to the point. -0.08. In the year 2001, what is the difference between the General Parity Index (GPI) in Czech Republic and General Parity Index (GPI) in Kenya?
Your answer should be very brief. 0.09. In the year 2001, what is the difference between the General Parity Index (GPI) of Czech Republic and General Parity Index (GPI) of Kyrgyz Republic?
Keep it short and to the point. 0.03. In the year 2001, what is the difference between the General Parity Index (GPI) of Kenya and General Parity Index (GPI) of Kyrgyz Republic?
Provide a short and direct response. -0.06. In the year 2002, what is the difference between the General Parity Index (GPI) of World and General Parity Index (GPI) of Czech Republic?
Keep it short and to the point. -0.1. In the year 2002, what is the difference between the General Parity Index (GPI) of World and General Parity Index (GPI) of Kenya?
Offer a very short reply. -0.03. In the year 2002, what is the difference between the General Parity Index (GPI) of World and General Parity Index (GPI) of Kyrgyz Republic?
Your response must be concise. -0.08. In the year 2002, what is the difference between the General Parity Index (GPI) of Czech Republic and General Parity Index (GPI) of Kenya?
Your answer should be compact. 0.07. In the year 2002, what is the difference between the General Parity Index (GPI) of Czech Republic and General Parity Index (GPI) of Kyrgyz Republic?
Ensure brevity in your answer.  0.03. In the year 2002, what is the difference between the General Parity Index (GPI) of Kenya and General Parity Index (GPI) of Kyrgyz Republic?
Provide a succinct answer. -0.05. In the year 2003, what is the difference between the General Parity Index (GPI) in World and General Parity Index (GPI) in Czech Republic?
Make the answer very short. -0.09. In the year 2003, what is the difference between the General Parity Index (GPI) in World and General Parity Index (GPI) in Kenya?
Offer a very short reply. -0.09. In the year 2003, what is the difference between the General Parity Index (GPI) in World and General Parity Index (GPI) in Kyrgyz Republic?
Your answer should be very brief. -0.07. In the year 2003, what is the difference between the General Parity Index (GPI) of Czech Republic and General Parity Index (GPI) of Kenya?
Ensure brevity in your answer.  0. In the year 2003, what is the difference between the General Parity Index (GPI) in Czech Republic and General Parity Index (GPI) in Kyrgyz Republic?
Your answer should be compact. 0.02. In the year 2003, what is the difference between the General Parity Index (GPI) in Kenya and General Parity Index (GPI) in Kyrgyz Republic?
Give a very brief answer. 0.02. In the year 2004, what is the difference between the General Parity Index (GPI) in World and General Parity Index (GPI) in Czech Republic?
Your answer should be very brief. -0.07. In the year 2004, what is the difference between the General Parity Index (GPI) of World and General Parity Index (GPI) of Kenya?
Your answer should be compact. 0. In the year 2004, what is the difference between the General Parity Index (GPI) in World and General Parity Index (GPI) in Kyrgyz Republic?
Ensure brevity in your answer.  -0.07. In the year 2004, what is the difference between the General Parity Index (GPI) of Czech Republic and General Parity Index (GPI) of Kenya?
Your answer should be compact. 0.08. In the year 2004, what is the difference between the General Parity Index (GPI) in Czech Republic and General Parity Index (GPI) in Kyrgyz Republic?
Provide a succinct answer. 0.01. In the year 2004, what is the difference between the General Parity Index (GPI) in Kenya and General Parity Index (GPI) in Kyrgyz Republic?
Your answer should be compact. -0.07. In the year 2005, what is the difference between the General Parity Index (GPI) in World and General Parity Index (GPI) in Czech Republic?
Your response must be concise. -0.07. In the year 2005, what is the difference between the General Parity Index (GPI) of World and General Parity Index (GPI) of Kenya?
Keep it short and to the point. -0.01. In the year 2005, what is the difference between the General Parity Index (GPI) in World and General Parity Index (GPI) in Kyrgyz Republic?
Make the answer very short. -0.05. In the year 2005, what is the difference between the General Parity Index (GPI) in Czech Republic and General Parity Index (GPI) in Kenya?
Give a very brief answer. 0.06. In the year 2005, what is the difference between the General Parity Index (GPI) in Czech Republic and General Parity Index (GPI) in Kyrgyz Republic?
Your answer should be very brief. 0.01. In the year 2005, what is the difference between the General Parity Index (GPI) of Kenya and General Parity Index (GPI) of Kyrgyz Republic?
Provide a short and direct response. -0.05. What is the ratio of the General Parity Index (GPI) in World in 1986 to that in 1999?
Your response must be concise. 0.91. What is the ratio of the General Parity Index (GPI) in Czech Republic in 1986 to that in 1999?
Give a very brief answer. 1.02. What is the ratio of the General Parity Index (GPI) of Kenya in 1986 to that in 1999?
Your response must be concise. 0.82. What is the ratio of the General Parity Index (GPI) of Kyrgyz Republic in 1986 to that in 1999?
Provide a succinct answer. 0.95. What is the ratio of the General Parity Index (GPI) in World in 1986 to that in 2000?
Offer a very short reply. 0.91. What is the ratio of the General Parity Index (GPI) in Czech Republic in 1986 to that in 2000?
Your answer should be very brief. 1.04. What is the ratio of the General Parity Index (GPI) in Kenya in 1986 to that in 2000?
Make the answer very short. 0.82. What is the ratio of the General Parity Index (GPI) in Kyrgyz Republic in 1986 to that in 2000?
Your answer should be very brief. 0.94. What is the ratio of the General Parity Index (GPI) of World in 1986 to that in 2001?
Your answer should be very brief. 0.9. What is the ratio of the General Parity Index (GPI) in Czech Republic in 1986 to that in 2001?
Your answer should be compact. 1.03. What is the ratio of the General Parity Index (GPI) in Kenya in 1986 to that in 2001?
Offer a terse response. 0.84. What is the ratio of the General Parity Index (GPI) of Kyrgyz Republic in 1986 to that in 2001?
Your answer should be compact. 0.97. What is the ratio of the General Parity Index (GPI) in World in 1986 to that in 2002?
Make the answer very short. 0.9. What is the ratio of the General Parity Index (GPI) of Czech Republic in 1986 to that in 2002?
Ensure brevity in your answer.  1.03. What is the ratio of the General Parity Index (GPI) in Kenya in 1986 to that in 2002?
Provide a succinct answer. 0.82. What is the ratio of the General Parity Index (GPI) in World in 1986 to that in 2003?
Offer a terse response. 0.89. What is the ratio of the General Parity Index (GPI) in Czech Republic in 1986 to that in 2003?
Provide a succinct answer. 1.04. What is the ratio of the General Parity Index (GPI) of Kenya in 1986 to that in 2003?
Keep it short and to the point. 0.77. What is the ratio of the General Parity Index (GPI) in Kyrgyz Republic in 1986 to that in 2003?
Offer a very short reply. 0.96. What is the ratio of the General Parity Index (GPI) in World in 1986 to that in 2004?
Offer a terse response. 0.88. What is the ratio of the General Parity Index (GPI) in Czech Republic in 1986 to that in 2004?
Your response must be concise. 1.05. What is the ratio of the General Parity Index (GPI) of Kenya in 1986 to that in 2004?
Ensure brevity in your answer.  0.84. What is the ratio of the General Parity Index (GPI) in Kyrgyz Republic in 1986 to that in 2004?
Offer a very short reply. 0.96. What is the ratio of the General Parity Index (GPI) of World in 1986 to that in 2005?
Your answer should be very brief. 0.88. What is the ratio of the General Parity Index (GPI) in Czech Republic in 1986 to that in 2005?
Give a very brief answer. 1.05. What is the ratio of the General Parity Index (GPI) in Kenya in 1986 to that in 2005?
Ensure brevity in your answer.  0.82. What is the ratio of the General Parity Index (GPI) in Kyrgyz Republic in 1986 to that in 2005?
Your answer should be very brief. 0.97. What is the ratio of the General Parity Index (GPI) in Czech Republic in 1999 to that in 2000?
Make the answer very short. 1.02. What is the ratio of the General Parity Index (GPI) of Czech Republic in 1999 to that in 2001?
Offer a very short reply. 1.01. What is the ratio of the General Parity Index (GPI) in Kenya in 1999 to that in 2001?
Offer a terse response. 1.02. What is the ratio of the General Parity Index (GPI) of Kyrgyz Republic in 1999 to that in 2001?
Keep it short and to the point. 1.02. What is the ratio of the General Parity Index (GPI) in World in 1999 to that in 2002?
Your response must be concise. 0.99. What is the ratio of the General Parity Index (GPI) in Czech Republic in 1999 to that in 2002?
Offer a very short reply. 1.01. What is the ratio of the General Parity Index (GPI) of Kyrgyz Republic in 1999 to that in 2002?
Provide a succinct answer. 1.02. What is the ratio of the General Parity Index (GPI) of World in 1999 to that in 2003?
Offer a very short reply. 0.98. What is the ratio of the General Parity Index (GPI) in Czech Republic in 1999 to that in 2003?
Provide a succinct answer. 1.02. What is the ratio of the General Parity Index (GPI) in Kenya in 1999 to that in 2003?
Provide a short and direct response. 0.93. What is the ratio of the General Parity Index (GPI) in Kyrgyz Republic in 1999 to that in 2003?
Offer a very short reply. 1.01. What is the ratio of the General Parity Index (GPI) in World in 1999 to that in 2004?
Ensure brevity in your answer.  0.97. What is the ratio of the General Parity Index (GPI) of Czech Republic in 1999 to that in 2004?
Offer a very short reply. 1.03. What is the ratio of the General Parity Index (GPI) of Kenya in 1999 to that in 2004?
Keep it short and to the point. 1.02. What is the ratio of the General Parity Index (GPI) in Kyrgyz Republic in 1999 to that in 2004?
Offer a terse response. 1.02. What is the ratio of the General Parity Index (GPI) in World in 1999 to that in 2005?
Keep it short and to the point. 0.97. What is the ratio of the General Parity Index (GPI) in Czech Republic in 1999 to that in 2005?
Provide a succinct answer. 1.03. What is the ratio of the General Parity Index (GPI) in Kenya in 1999 to that in 2005?
Keep it short and to the point. 1. What is the ratio of the General Parity Index (GPI) in Kyrgyz Republic in 1999 to that in 2005?
Keep it short and to the point. 1.02. What is the ratio of the General Parity Index (GPI) of Czech Republic in 2000 to that in 2001?
Your answer should be very brief. 0.99. What is the ratio of the General Parity Index (GPI) in Kenya in 2000 to that in 2001?
Provide a short and direct response. 1.01. What is the ratio of the General Parity Index (GPI) of Kyrgyz Republic in 2000 to that in 2001?
Make the answer very short. 1.03. What is the ratio of the General Parity Index (GPI) in Kyrgyz Republic in 2000 to that in 2002?
Provide a succinct answer. 1.03. What is the ratio of the General Parity Index (GPI) of World in 2000 to that in 2003?
Provide a short and direct response. 0.98. What is the ratio of the General Parity Index (GPI) in Czech Republic in 2000 to that in 2003?
Give a very brief answer. 0.99. What is the ratio of the General Parity Index (GPI) of Kenya in 2000 to that in 2003?
Offer a terse response. 0.93. What is the ratio of the General Parity Index (GPI) in Kyrgyz Republic in 2000 to that in 2003?
Your answer should be compact. 1.02. What is the ratio of the General Parity Index (GPI) of World in 2000 to that in 2004?
Keep it short and to the point. 0.98. What is the ratio of the General Parity Index (GPI) of Czech Republic in 2000 to that in 2004?
Ensure brevity in your answer.  1.01. What is the ratio of the General Parity Index (GPI) in Kenya in 2000 to that in 2004?
Keep it short and to the point. 1.02. What is the ratio of the General Parity Index (GPI) in World in 2000 to that in 2005?
Provide a succinct answer. 0.97. What is the ratio of the General Parity Index (GPI) of Czech Republic in 2000 to that in 2005?
Your answer should be very brief. 1. What is the ratio of the General Parity Index (GPI) in Kenya in 2000 to that in 2005?
Ensure brevity in your answer.  1. What is the ratio of the General Parity Index (GPI) of Kyrgyz Republic in 2000 to that in 2005?
Ensure brevity in your answer.  1.03. What is the ratio of the General Parity Index (GPI) of World in 2001 to that in 2002?
Provide a short and direct response. 1. What is the ratio of the General Parity Index (GPI) of Czech Republic in 2001 to that in 2002?
Offer a very short reply. 1. What is the ratio of the General Parity Index (GPI) of Kenya in 2001 to that in 2002?
Keep it short and to the point. 0.98. What is the ratio of the General Parity Index (GPI) in Kyrgyz Republic in 2001 to that in 2002?
Offer a very short reply. 1. What is the ratio of the General Parity Index (GPI) of World in 2001 to that in 2003?
Provide a succinct answer. 0.98. What is the ratio of the General Parity Index (GPI) of Czech Republic in 2001 to that in 2003?
Make the answer very short. 1. What is the ratio of the General Parity Index (GPI) in Kenya in 2001 to that in 2003?
Your answer should be very brief. 0.92. What is the ratio of the General Parity Index (GPI) of World in 2001 to that in 2004?
Provide a short and direct response. 0.98. What is the ratio of the General Parity Index (GPI) in Czech Republic in 2001 to that in 2004?
Offer a very short reply. 1.02. What is the ratio of the General Parity Index (GPI) in World in 2001 to that in 2005?
Provide a succinct answer. 0.97. What is the ratio of the General Parity Index (GPI) of Czech Republic in 2001 to that in 2005?
Offer a terse response. 1.02. What is the ratio of the General Parity Index (GPI) of Kenya in 2001 to that in 2005?
Keep it short and to the point. 0.98. What is the ratio of the General Parity Index (GPI) in Kyrgyz Republic in 2001 to that in 2005?
Make the answer very short. 1. What is the ratio of the General Parity Index (GPI) of World in 2002 to that in 2003?
Your answer should be compact. 0.99. What is the ratio of the General Parity Index (GPI) in Kenya in 2002 to that in 2003?
Make the answer very short. 0.93. What is the ratio of the General Parity Index (GPI) of World in 2002 to that in 2004?
Provide a short and direct response. 0.98. What is the ratio of the General Parity Index (GPI) of Czech Republic in 2002 to that in 2004?
Offer a terse response. 1.02. What is the ratio of the General Parity Index (GPI) of Kenya in 2002 to that in 2004?
Your response must be concise. 1.02. What is the ratio of the General Parity Index (GPI) in Kyrgyz Republic in 2002 to that in 2004?
Give a very brief answer. 1. What is the ratio of the General Parity Index (GPI) of World in 2002 to that in 2005?
Make the answer very short. 0.98. What is the ratio of the General Parity Index (GPI) in Czech Republic in 2002 to that in 2005?
Give a very brief answer. 1.01. What is the ratio of the General Parity Index (GPI) in Kenya in 2002 to that in 2005?
Offer a terse response. 1. What is the ratio of the General Parity Index (GPI) in Kyrgyz Republic in 2002 to that in 2005?
Provide a short and direct response. 1. What is the ratio of the General Parity Index (GPI) in Czech Republic in 2003 to that in 2004?
Provide a short and direct response. 1.01. What is the ratio of the General Parity Index (GPI) of Kenya in 2003 to that in 2004?
Offer a terse response. 1.1. What is the ratio of the General Parity Index (GPI) in Kyrgyz Republic in 2003 to that in 2004?
Provide a succinct answer. 1. What is the ratio of the General Parity Index (GPI) in Czech Republic in 2003 to that in 2005?
Make the answer very short. 1.01. What is the ratio of the General Parity Index (GPI) in Kenya in 2003 to that in 2005?
Offer a terse response. 1.07. What is the ratio of the General Parity Index (GPI) of Kyrgyz Republic in 2003 to that in 2005?
Your answer should be compact. 1.01. What is the ratio of the General Parity Index (GPI) in World in 2004 to that in 2005?
Make the answer very short. 0.99. What is the ratio of the General Parity Index (GPI) in Czech Republic in 2004 to that in 2005?
Keep it short and to the point. 1. What is the ratio of the General Parity Index (GPI) in Kenya in 2004 to that in 2005?
Keep it short and to the point. 0.98. What is the difference between the highest and the second highest General Parity Index (GPI) in World?
Provide a short and direct response. 0.01. What is the difference between the highest and the second highest General Parity Index (GPI) of Czech Republic?
Offer a terse response. 0.02. What is the difference between the highest and the second highest General Parity Index (GPI) of Kenya?
Your answer should be very brief. 0.07. What is the difference between the highest and the second highest General Parity Index (GPI) of Kyrgyz Republic?
Make the answer very short. 0.01. What is the difference between the highest and the lowest General Parity Index (GPI) of World?
Your response must be concise. 0.12. What is the difference between the highest and the lowest General Parity Index (GPI) in Czech Republic?
Make the answer very short. 0.05. What is the difference between the highest and the lowest General Parity Index (GPI) of Kenya?
Give a very brief answer. 0.24. What is the difference between the highest and the lowest General Parity Index (GPI) of Kyrgyz Republic?
Ensure brevity in your answer.  0.06. 